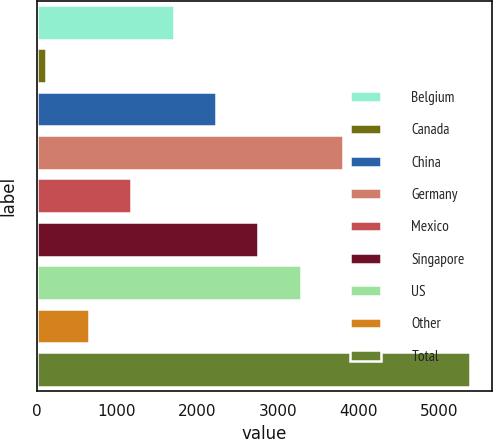Convert chart. <chart><loc_0><loc_0><loc_500><loc_500><bar_chart><fcel>Belgium<fcel>Canada<fcel>China<fcel>Germany<fcel>Mexico<fcel>Singapore<fcel>US<fcel>Other<fcel>Total<nl><fcel>1702.8<fcel>123<fcel>2229.4<fcel>3809.2<fcel>1176.2<fcel>2756<fcel>3282.6<fcel>649.6<fcel>5389<nl></chart> 